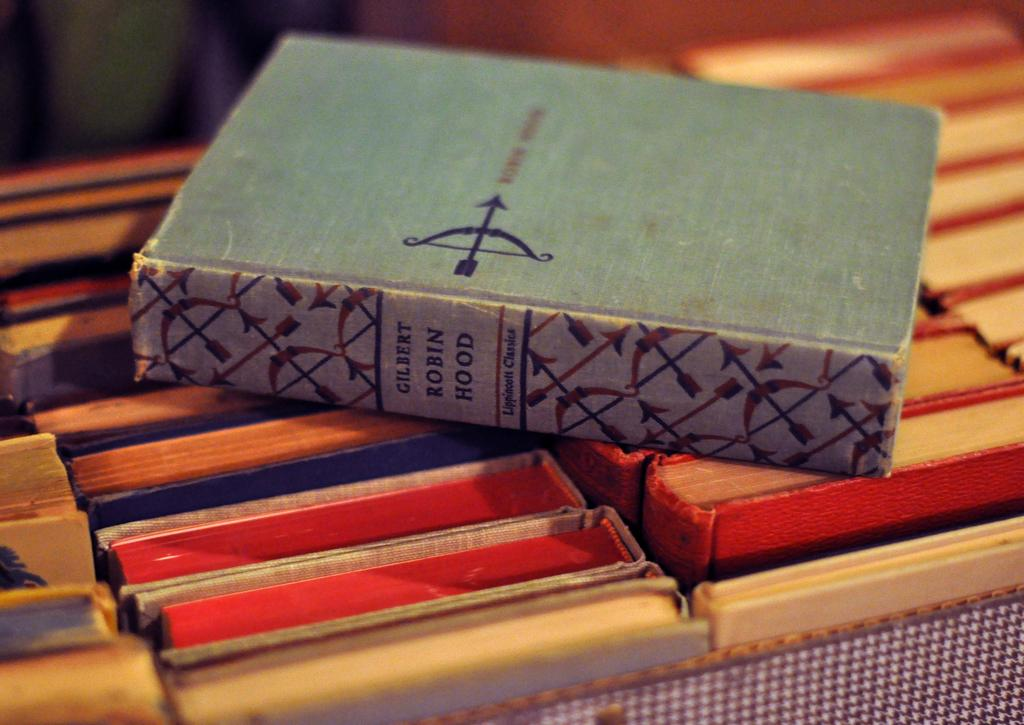What is placed on top of other objects in the image? There is a book placed on other books in the image. Can you describe the arrangement of the books in the image? The book is placed on top of other books, suggesting a stack or pile of books. What type of fish can be seen swimming in the image? There is no fish present in the image; it features a book placed on other books. What noise can be heard coming from the button in the image? There is no button present in the image, so it's not possible to determine what noise might be heard. 